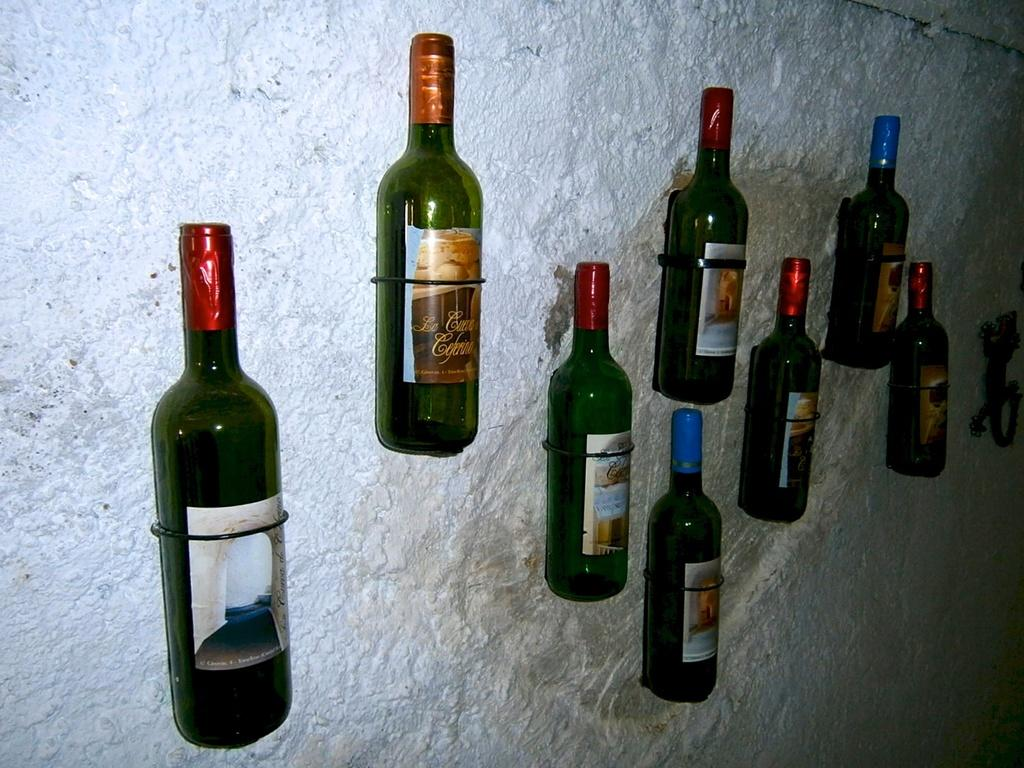What objects are present in the image? There are bottles in the image. Where are the bottles located? The bottles are attached to a wall. What type of stitch is used to attach the bottles to the wall in the image? There is no stitching visible in the image, as the bottles are attached to the wall in some other manner. 